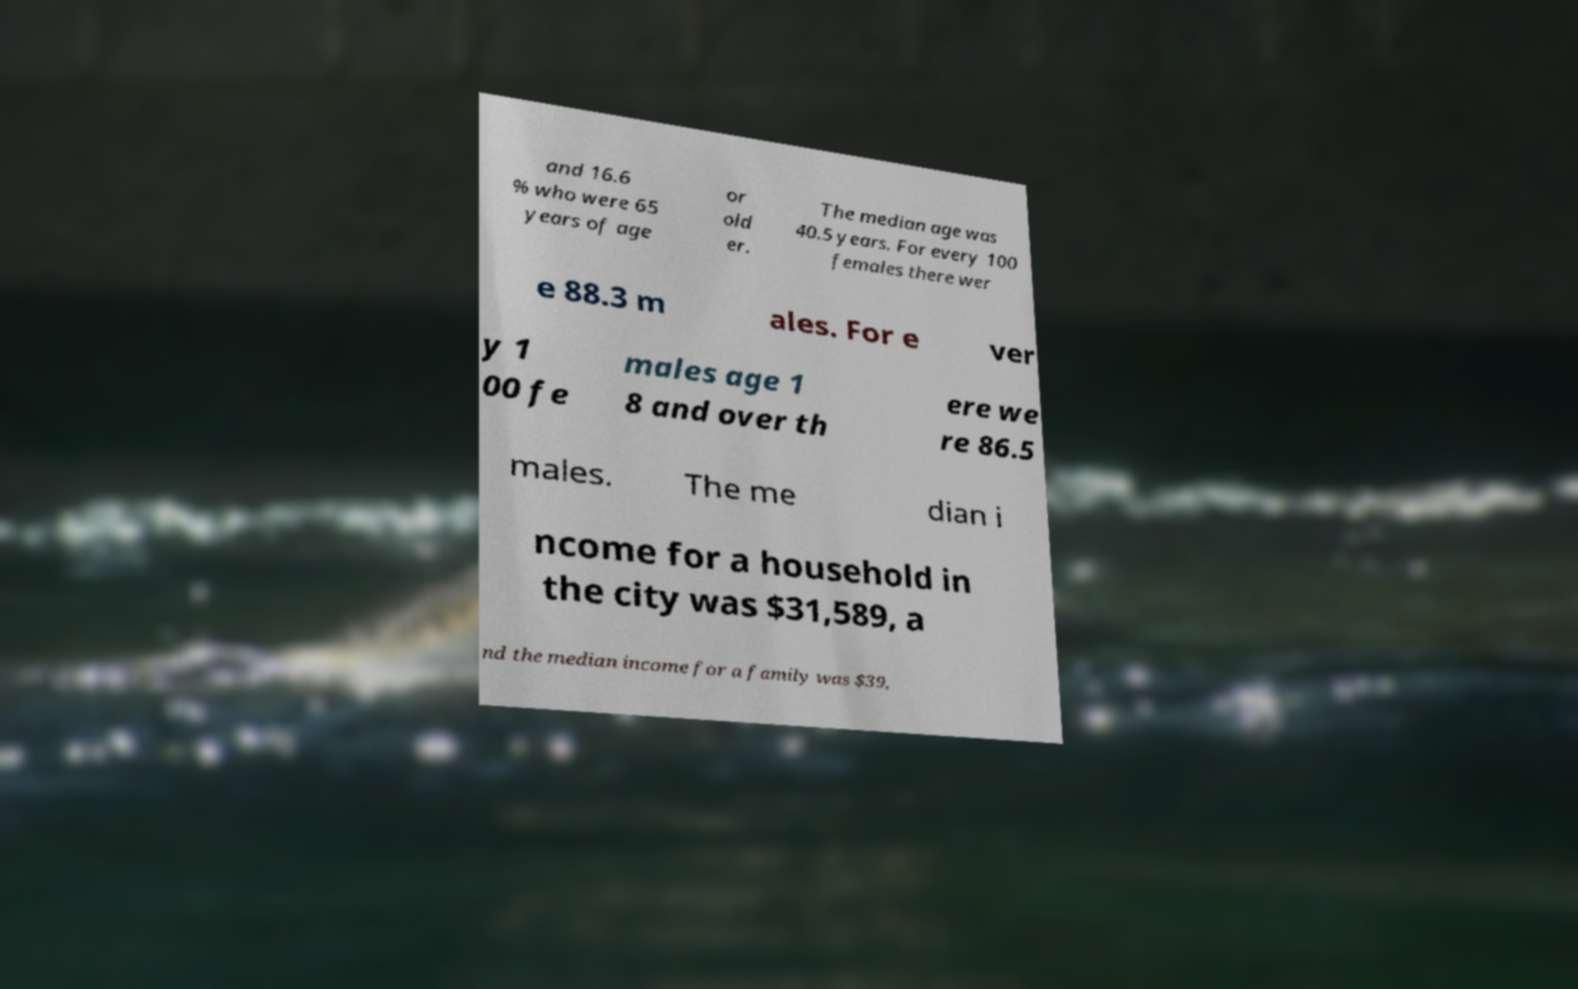What messages or text are displayed in this image? I need them in a readable, typed format. and 16.6 % who were 65 years of age or old er. The median age was 40.5 years. For every 100 females there wer e 88.3 m ales. For e ver y 1 00 fe males age 1 8 and over th ere we re 86.5 males. The me dian i ncome for a household in the city was $31,589, a nd the median income for a family was $39, 